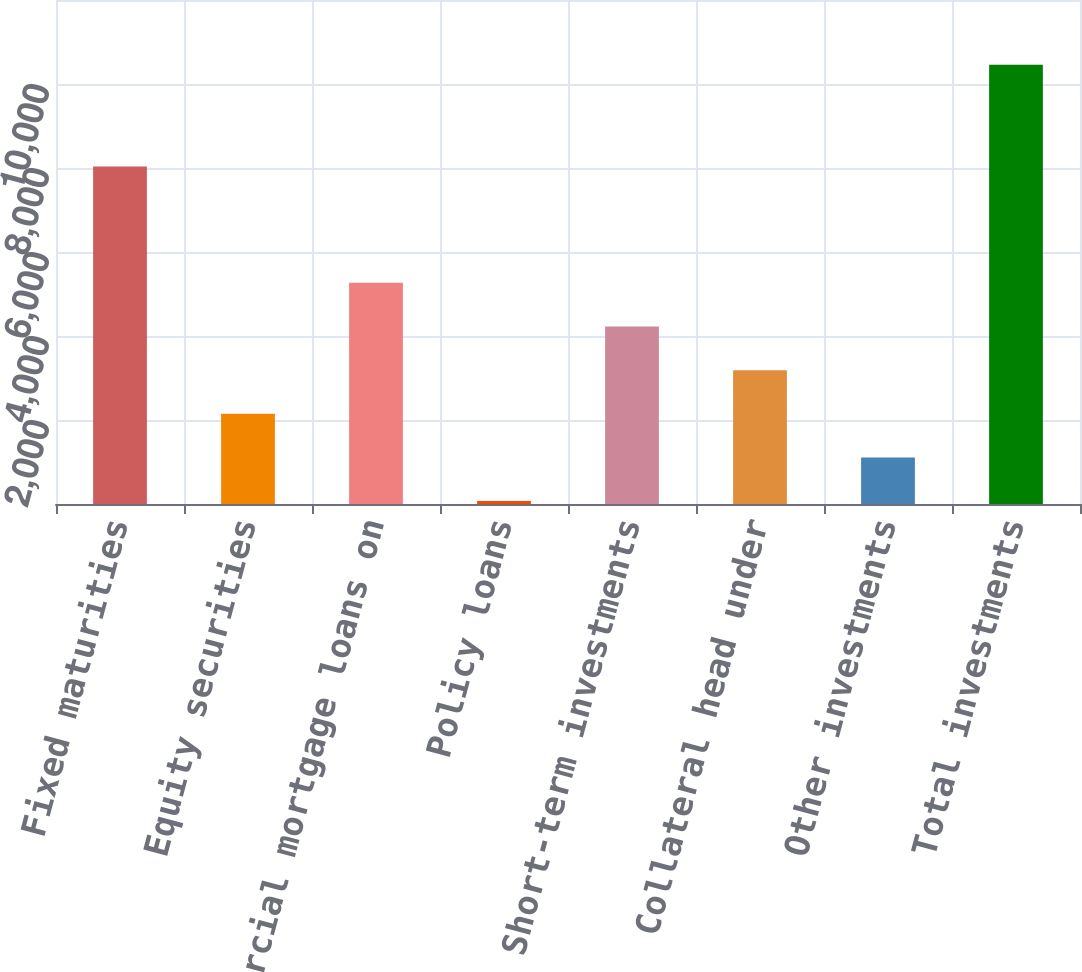Convert chart. <chart><loc_0><loc_0><loc_500><loc_500><bar_chart><fcel>Fixed maturities<fcel>Equity securities<fcel>Commercial mortgage loans on<fcel>Policy loans<fcel>Short-term investments<fcel>Collateral head under<fcel>Other investments<fcel>Total investments<nl><fcel>8036<fcel>2147.4<fcel>5265<fcel>69<fcel>4225.8<fcel>3186.6<fcel>1108.2<fcel>10461<nl></chart> 